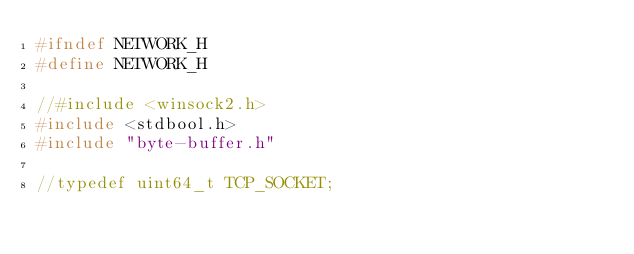<code> <loc_0><loc_0><loc_500><loc_500><_C_>#ifndef NETWORK_H
#define NETWORK_H

//#include <winsock2.h>
#include <stdbool.h>
#include "byte-buffer.h"

//typedef uint64_t TCP_SOCKET;
</code> 